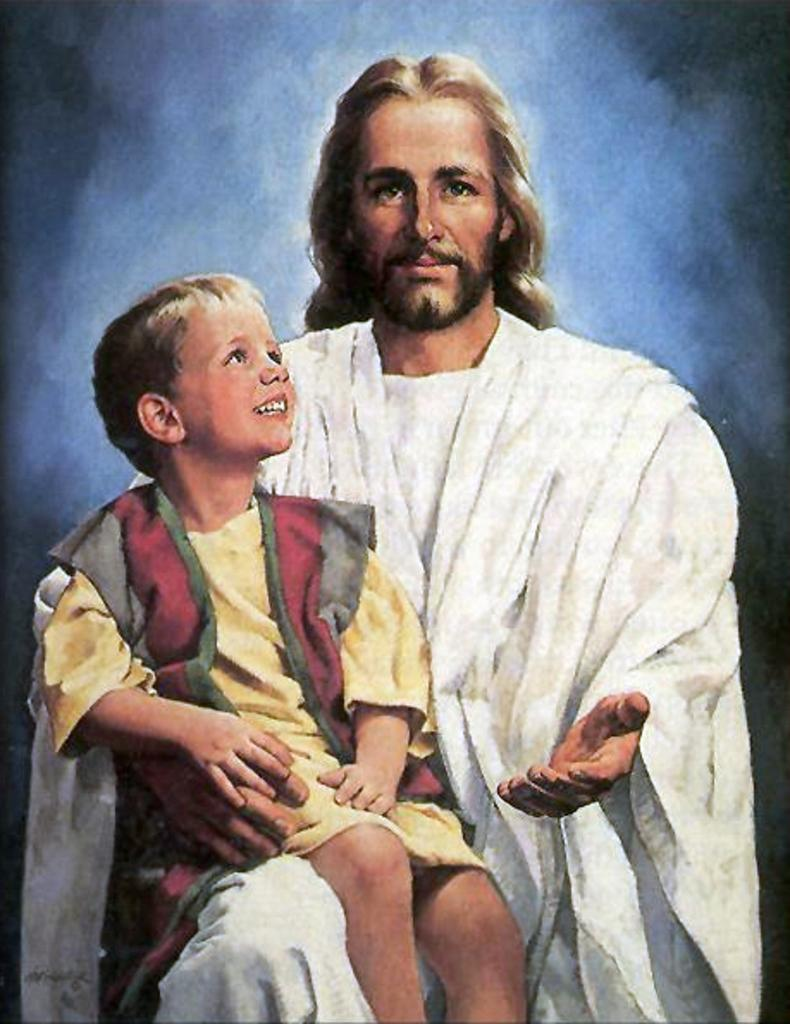What is the main subject of the image? The main subject of the image is a person sitting in the center. What is the person doing in the image? The person is holding a kid. How are the person and the kid feeling in the image? The person and the kid are both smiling. What type of trade is being conducted in the image? There is no trade being conducted in the image; it features a person holding a kid. What books can be seen on the sofa in the image? There is no sofa or books present in the image. 